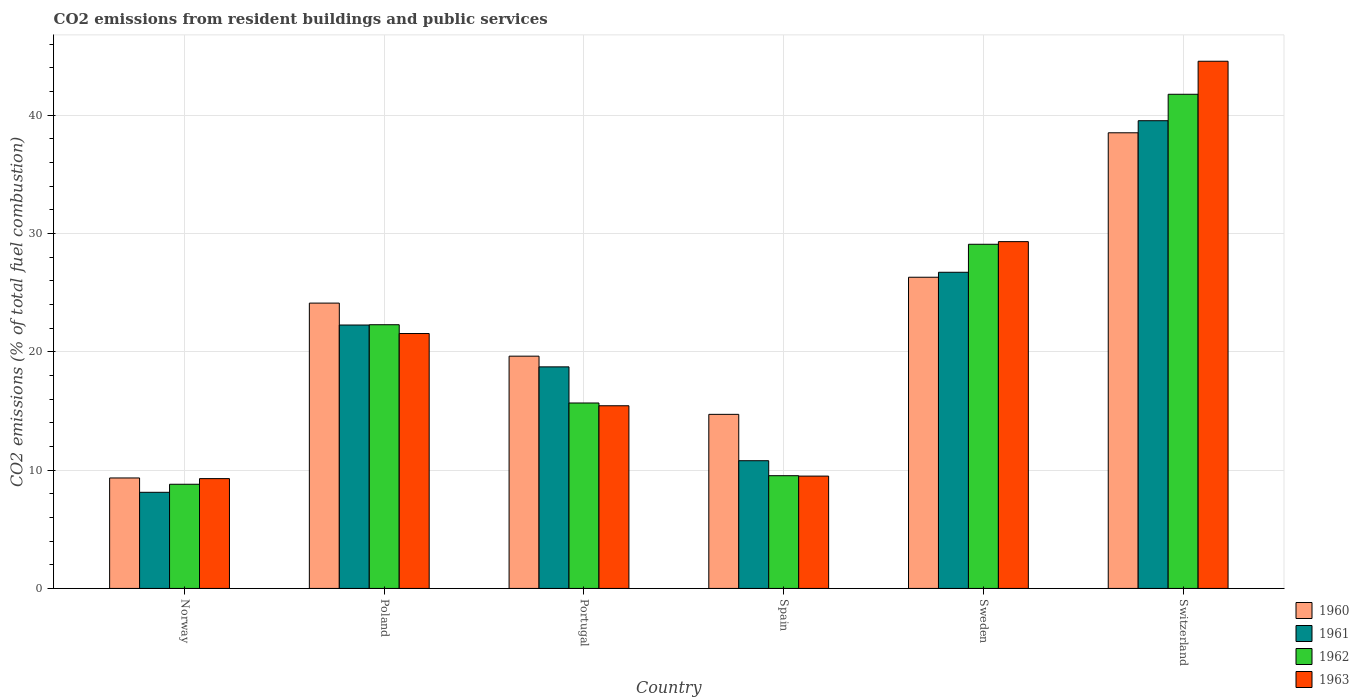How many different coloured bars are there?
Your response must be concise. 4. Are the number of bars per tick equal to the number of legend labels?
Offer a very short reply. Yes. How many bars are there on the 1st tick from the left?
Make the answer very short. 4. What is the total CO2 emitted in 1961 in Poland?
Offer a very short reply. 22.27. Across all countries, what is the maximum total CO2 emitted in 1962?
Ensure brevity in your answer.  41.78. Across all countries, what is the minimum total CO2 emitted in 1960?
Provide a succinct answer. 9.34. In which country was the total CO2 emitted in 1961 maximum?
Keep it short and to the point. Switzerland. What is the total total CO2 emitted in 1960 in the graph?
Make the answer very short. 132.65. What is the difference between the total CO2 emitted in 1963 in Poland and that in Portugal?
Offer a terse response. 6.11. What is the difference between the total CO2 emitted in 1963 in Portugal and the total CO2 emitted in 1960 in Poland?
Ensure brevity in your answer.  -8.68. What is the average total CO2 emitted in 1963 per country?
Your response must be concise. 21.61. What is the difference between the total CO2 emitted of/in 1961 and total CO2 emitted of/in 1960 in Poland?
Offer a terse response. -1.85. What is the ratio of the total CO2 emitted in 1963 in Norway to that in Sweden?
Your answer should be compact. 0.32. Is the total CO2 emitted in 1962 in Portugal less than that in Spain?
Keep it short and to the point. No. What is the difference between the highest and the second highest total CO2 emitted in 1963?
Give a very brief answer. -23.02. What is the difference between the highest and the lowest total CO2 emitted in 1963?
Keep it short and to the point. 35.29. In how many countries, is the total CO2 emitted in 1960 greater than the average total CO2 emitted in 1960 taken over all countries?
Provide a short and direct response. 3. Is it the case that in every country, the sum of the total CO2 emitted in 1960 and total CO2 emitted in 1962 is greater than the sum of total CO2 emitted in 1963 and total CO2 emitted in 1961?
Provide a short and direct response. No. What does the 3rd bar from the left in Poland represents?
Your answer should be compact. 1962. What does the 1st bar from the right in Poland represents?
Give a very brief answer. 1963. How many bars are there?
Keep it short and to the point. 24. Does the graph contain grids?
Make the answer very short. Yes. What is the title of the graph?
Give a very brief answer. CO2 emissions from resident buildings and public services. What is the label or title of the X-axis?
Offer a very short reply. Country. What is the label or title of the Y-axis?
Your answer should be very brief. CO2 emissions (% of total fuel combustion). What is the CO2 emissions (% of total fuel combustion) of 1960 in Norway?
Offer a very short reply. 9.34. What is the CO2 emissions (% of total fuel combustion) in 1961 in Norway?
Keep it short and to the point. 8.13. What is the CO2 emissions (% of total fuel combustion) in 1962 in Norway?
Your answer should be very brief. 8.81. What is the CO2 emissions (% of total fuel combustion) in 1963 in Norway?
Provide a short and direct response. 9.28. What is the CO2 emissions (% of total fuel combustion) of 1960 in Poland?
Keep it short and to the point. 24.12. What is the CO2 emissions (% of total fuel combustion) in 1961 in Poland?
Provide a short and direct response. 22.27. What is the CO2 emissions (% of total fuel combustion) of 1962 in Poland?
Keep it short and to the point. 22.3. What is the CO2 emissions (% of total fuel combustion) in 1963 in Poland?
Your response must be concise. 21.55. What is the CO2 emissions (% of total fuel combustion) of 1960 in Portugal?
Offer a terse response. 19.64. What is the CO2 emissions (% of total fuel combustion) in 1961 in Portugal?
Keep it short and to the point. 18.73. What is the CO2 emissions (% of total fuel combustion) in 1962 in Portugal?
Make the answer very short. 15.68. What is the CO2 emissions (% of total fuel combustion) in 1963 in Portugal?
Ensure brevity in your answer.  15.44. What is the CO2 emissions (% of total fuel combustion) of 1960 in Spain?
Provide a short and direct response. 14.72. What is the CO2 emissions (% of total fuel combustion) of 1961 in Spain?
Your answer should be very brief. 10.8. What is the CO2 emissions (% of total fuel combustion) in 1962 in Spain?
Offer a terse response. 9.53. What is the CO2 emissions (% of total fuel combustion) of 1963 in Spain?
Give a very brief answer. 9.5. What is the CO2 emissions (% of total fuel combustion) of 1960 in Sweden?
Keep it short and to the point. 26.31. What is the CO2 emissions (% of total fuel combustion) in 1961 in Sweden?
Your answer should be very brief. 26.73. What is the CO2 emissions (% of total fuel combustion) in 1962 in Sweden?
Ensure brevity in your answer.  29.1. What is the CO2 emissions (% of total fuel combustion) in 1963 in Sweden?
Make the answer very short. 29.32. What is the CO2 emissions (% of total fuel combustion) of 1960 in Switzerland?
Provide a short and direct response. 38.52. What is the CO2 emissions (% of total fuel combustion) in 1961 in Switzerland?
Make the answer very short. 39.54. What is the CO2 emissions (% of total fuel combustion) of 1962 in Switzerland?
Provide a short and direct response. 41.78. What is the CO2 emissions (% of total fuel combustion) of 1963 in Switzerland?
Your response must be concise. 44.57. Across all countries, what is the maximum CO2 emissions (% of total fuel combustion) in 1960?
Your answer should be very brief. 38.52. Across all countries, what is the maximum CO2 emissions (% of total fuel combustion) of 1961?
Keep it short and to the point. 39.54. Across all countries, what is the maximum CO2 emissions (% of total fuel combustion) of 1962?
Offer a terse response. 41.78. Across all countries, what is the maximum CO2 emissions (% of total fuel combustion) in 1963?
Provide a short and direct response. 44.57. Across all countries, what is the minimum CO2 emissions (% of total fuel combustion) in 1960?
Keep it short and to the point. 9.34. Across all countries, what is the minimum CO2 emissions (% of total fuel combustion) in 1961?
Offer a terse response. 8.13. Across all countries, what is the minimum CO2 emissions (% of total fuel combustion) of 1962?
Your response must be concise. 8.81. Across all countries, what is the minimum CO2 emissions (% of total fuel combustion) in 1963?
Ensure brevity in your answer.  9.28. What is the total CO2 emissions (% of total fuel combustion) of 1960 in the graph?
Your answer should be compact. 132.65. What is the total CO2 emissions (% of total fuel combustion) of 1961 in the graph?
Provide a short and direct response. 126.2. What is the total CO2 emissions (% of total fuel combustion) in 1962 in the graph?
Provide a succinct answer. 127.19. What is the total CO2 emissions (% of total fuel combustion) in 1963 in the graph?
Your answer should be very brief. 129.67. What is the difference between the CO2 emissions (% of total fuel combustion) in 1960 in Norway and that in Poland?
Keep it short and to the point. -14.78. What is the difference between the CO2 emissions (% of total fuel combustion) of 1961 in Norway and that in Poland?
Your answer should be compact. -14.14. What is the difference between the CO2 emissions (% of total fuel combustion) in 1962 in Norway and that in Poland?
Your answer should be very brief. -13.49. What is the difference between the CO2 emissions (% of total fuel combustion) in 1963 in Norway and that in Poland?
Give a very brief answer. -12.27. What is the difference between the CO2 emissions (% of total fuel combustion) in 1960 in Norway and that in Portugal?
Provide a short and direct response. -10.3. What is the difference between the CO2 emissions (% of total fuel combustion) in 1961 in Norway and that in Portugal?
Offer a terse response. -10.61. What is the difference between the CO2 emissions (% of total fuel combustion) of 1962 in Norway and that in Portugal?
Ensure brevity in your answer.  -6.87. What is the difference between the CO2 emissions (% of total fuel combustion) of 1963 in Norway and that in Portugal?
Ensure brevity in your answer.  -6.16. What is the difference between the CO2 emissions (% of total fuel combustion) in 1960 in Norway and that in Spain?
Make the answer very short. -5.38. What is the difference between the CO2 emissions (% of total fuel combustion) of 1961 in Norway and that in Spain?
Make the answer very short. -2.67. What is the difference between the CO2 emissions (% of total fuel combustion) of 1962 in Norway and that in Spain?
Offer a terse response. -0.72. What is the difference between the CO2 emissions (% of total fuel combustion) of 1963 in Norway and that in Spain?
Provide a short and direct response. -0.21. What is the difference between the CO2 emissions (% of total fuel combustion) in 1960 in Norway and that in Sweden?
Ensure brevity in your answer.  -16.97. What is the difference between the CO2 emissions (% of total fuel combustion) of 1961 in Norway and that in Sweden?
Ensure brevity in your answer.  -18.6. What is the difference between the CO2 emissions (% of total fuel combustion) of 1962 in Norway and that in Sweden?
Ensure brevity in your answer.  -20.29. What is the difference between the CO2 emissions (% of total fuel combustion) of 1963 in Norway and that in Sweden?
Ensure brevity in your answer.  -20.04. What is the difference between the CO2 emissions (% of total fuel combustion) in 1960 in Norway and that in Switzerland?
Provide a short and direct response. -29.18. What is the difference between the CO2 emissions (% of total fuel combustion) of 1961 in Norway and that in Switzerland?
Make the answer very short. -31.42. What is the difference between the CO2 emissions (% of total fuel combustion) of 1962 in Norway and that in Switzerland?
Your answer should be very brief. -32.97. What is the difference between the CO2 emissions (% of total fuel combustion) in 1963 in Norway and that in Switzerland?
Ensure brevity in your answer.  -35.29. What is the difference between the CO2 emissions (% of total fuel combustion) in 1960 in Poland and that in Portugal?
Provide a short and direct response. 4.49. What is the difference between the CO2 emissions (% of total fuel combustion) of 1961 in Poland and that in Portugal?
Your answer should be very brief. 3.54. What is the difference between the CO2 emissions (% of total fuel combustion) of 1962 in Poland and that in Portugal?
Your response must be concise. 6.62. What is the difference between the CO2 emissions (% of total fuel combustion) in 1963 in Poland and that in Portugal?
Make the answer very short. 6.11. What is the difference between the CO2 emissions (% of total fuel combustion) in 1960 in Poland and that in Spain?
Provide a short and direct response. 9.41. What is the difference between the CO2 emissions (% of total fuel combustion) of 1961 in Poland and that in Spain?
Offer a very short reply. 11.47. What is the difference between the CO2 emissions (% of total fuel combustion) of 1962 in Poland and that in Spain?
Offer a very short reply. 12.76. What is the difference between the CO2 emissions (% of total fuel combustion) of 1963 in Poland and that in Spain?
Your answer should be very brief. 12.05. What is the difference between the CO2 emissions (% of total fuel combustion) of 1960 in Poland and that in Sweden?
Provide a succinct answer. -2.19. What is the difference between the CO2 emissions (% of total fuel combustion) of 1961 in Poland and that in Sweden?
Keep it short and to the point. -4.46. What is the difference between the CO2 emissions (% of total fuel combustion) in 1962 in Poland and that in Sweden?
Provide a short and direct response. -6.8. What is the difference between the CO2 emissions (% of total fuel combustion) in 1963 in Poland and that in Sweden?
Keep it short and to the point. -7.77. What is the difference between the CO2 emissions (% of total fuel combustion) in 1960 in Poland and that in Switzerland?
Your answer should be compact. -14.4. What is the difference between the CO2 emissions (% of total fuel combustion) of 1961 in Poland and that in Switzerland?
Give a very brief answer. -17.27. What is the difference between the CO2 emissions (% of total fuel combustion) in 1962 in Poland and that in Switzerland?
Your answer should be very brief. -19.48. What is the difference between the CO2 emissions (% of total fuel combustion) of 1963 in Poland and that in Switzerland?
Make the answer very short. -23.02. What is the difference between the CO2 emissions (% of total fuel combustion) in 1960 in Portugal and that in Spain?
Keep it short and to the point. 4.92. What is the difference between the CO2 emissions (% of total fuel combustion) of 1961 in Portugal and that in Spain?
Keep it short and to the point. 7.93. What is the difference between the CO2 emissions (% of total fuel combustion) in 1962 in Portugal and that in Spain?
Make the answer very short. 6.15. What is the difference between the CO2 emissions (% of total fuel combustion) of 1963 in Portugal and that in Spain?
Ensure brevity in your answer.  5.95. What is the difference between the CO2 emissions (% of total fuel combustion) of 1960 in Portugal and that in Sweden?
Offer a terse response. -6.67. What is the difference between the CO2 emissions (% of total fuel combustion) of 1961 in Portugal and that in Sweden?
Offer a very short reply. -8. What is the difference between the CO2 emissions (% of total fuel combustion) of 1962 in Portugal and that in Sweden?
Your answer should be very brief. -13.42. What is the difference between the CO2 emissions (% of total fuel combustion) in 1963 in Portugal and that in Sweden?
Offer a very short reply. -13.88. What is the difference between the CO2 emissions (% of total fuel combustion) of 1960 in Portugal and that in Switzerland?
Offer a very short reply. -18.88. What is the difference between the CO2 emissions (% of total fuel combustion) of 1961 in Portugal and that in Switzerland?
Offer a very short reply. -20.81. What is the difference between the CO2 emissions (% of total fuel combustion) in 1962 in Portugal and that in Switzerland?
Make the answer very short. -26.1. What is the difference between the CO2 emissions (% of total fuel combustion) of 1963 in Portugal and that in Switzerland?
Keep it short and to the point. -29.13. What is the difference between the CO2 emissions (% of total fuel combustion) in 1960 in Spain and that in Sweden?
Offer a very short reply. -11.59. What is the difference between the CO2 emissions (% of total fuel combustion) of 1961 in Spain and that in Sweden?
Your answer should be very brief. -15.93. What is the difference between the CO2 emissions (% of total fuel combustion) in 1962 in Spain and that in Sweden?
Your answer should be compact. -19.57. What is the difference between the CO2 emissions (% of total fuel combustion) of 1963 in Spain and that in Sweden?
Give a very brief answer. -19.82. What is the difference between the CO2 emissions (% of total fuel combustion) in 1960 in Spain and that in Switzerland?
Your answer should be compact. -23.8. What is the difference between the CO2 emissions (% of total fuel combustion) of 1961 in Spain and that in Switzerland?
Offer a terse response. -28.75. What is the difference between the CO2 emissions (% of total fuel combustion) of 1962 in Spain and that in Switzerland?
Ensure brevity in your answer.  -32.25. What is the difference between the CO2 emissions (% of total fuel combustion) in 1963 in Spain and that in Switzerland?
Ensure brevity in your answer.  -35.07. What is the difference between the CO2 emissions (% of total fuel combustion) in 1960 in Sweden and that in Switzerland?
Give a very brief answer. -12.21. What is the difference between the CO2 emissions (% of total fuel combustion) of 1961 in Sweden and that in Switzerland?
Keep it short and to the point. -12.81. What is the difference between the CO2 emissions (% of total fuel combustion) of 1962 in Sweden and that in Switzerland?
Ensure brevity in your answer.  -12.68. What is the difference between the CO2 emissions (% of total fuel combustion) in 1963 in Sweden and that in Switzerland?
Make the answer very short. -15.25. What is the difference between the CO2 emissions (% of total fuel combustion) in 1960 in Norway and the CO2 emissions (% of total fuel combustion) in 1961 in Poland?
Make the answer very short. -12.93. What is the difference between the CO2 emissions (% of total fuel combustion) of 1960 in Norway and the CO2 emissions (% of total fuel combustion) of 1962 in Poland?
Make the answer very short. -12.96. What is the difference between the CO2 emissions (% of total fuel combustion) of 1960 in Norway and the CO2 emissions (% of total fuel combustion) of 1963 in Poland?
Provide a succinct answer. -12.21. What is the difference between the CO2 emissions (% of total fuel combustion) of 1961 in Norway and the CO2 emissions (% of total fuel combustion) of 1962 in Poland?
Your response must be concise. -14.17. What is the difference between the CO2 emissions (% of total fuel combustion) in 1961 in Norway and the CO2 emissions (% of total fuel combustion) in 1963 in Poland?
Offer a very short reply. -13.42. What is the difference between the CO2 emissions (% of total fuel combustion) in 1962 in Norway and the CO2 emissions (% of total fuel combustion) in 1963 in Poland?
Your response must be concise. -12.74. What is the difference between the CO2 emissions (% of total fuel combustion) in 1960 in Norway and the CO2 emissions (% of total fuel combustion) in 1961 in Portugal?
Give a very brief answer. -9.39. What is the difference between the CO2 emissions (% of total fuel combustion) of 1960 in Norway and the CO2 emissions (% of total fuel combustion) of 1962 in Portugal?
Your answer should be compact. -6.34. What is the difference between the CO2 emissions (% of total fuel combustion) of 1960 in Norway and the CO2 emissions (% of total fuel combustion) of 1963 in Portugal?
Ensure brevity in your answer.  -6.1. What is the difference between the CO2 emissions (% of total fuel combustion) of 1961 in Norway and the CO2 emissions (% of total fuel combustion) of 1962 in Portugal?
Your answer should be compact. -7.55. What is the difference between the CO2 emissions (% of total fuel combustion) in 1961 in Norway and the CO2 emissions (% of total fuel combustion) in 1963 in Portugal?
Give a very brief answer. -7.32. What is the difference between the CO2 emissions (% of total fuel combustion) of 1962 in Norway and the CO2 emissions (% of total fuel combustion) of 1963 in Portugal?
Your answer should be compact. -6.64. What is the difference between the CO2 emissions (% of total fuel combustion) in 1960 in Norway and the CO2 emissions (% of total fuel combustion) in 1961 in Spain?
Give a very brief answer. -1.46. What is the difference between the CO2 emissions (% of total fuel combustion) in 1960 in Norway and the CO2 emissions (% of total fuel combustion) in 1962 in Spain?
Provide a short and direct response. -0.19. What is the difference between the CO2 emissions (% of total fuel combustion) of 1960 in Norway and the CO2 emissions (% of total fuel combustion) of 1963 in Spain?
Offer a very short reply. -0.16. What is the difference between the CO2 emissions (% of total fuel combustion) in 1961 in Norway and the CO2 emissions (% of total fuel combustion) in 1962 in Spain?
Provide a succinct answer. -1.4. What is the difference between the CO2 emissions (% of total fuel combustion) of 1961 in Norway and the CO2 emissions (% of total fuel combustion) of 1963 in Spain?
Give a very brief answer. -1.37. What is the difference between the CO2 emissions (% of total fuel combustion) in 1962 in Norway and the CO2 emissions (% of total fuel combustion) in 1963 in Spain?
Your answer should be very brief. -0.69. What is the difference between the CO2 emissions (% of total fuel combustion) of 1960 in Norway and the CO2 emissions (% of total fuel combustion) of 1961 in Sweden?
Offer a very short reply. -17.39. What is the difference between the CO2 emissions (% of total fuel combustion) in 1960 in Norway and the CO2 emissions (% of total fuel combustion) in 1962 in Sweden?
Provide a short and direct response. -19.76. What is the difference between the CO2 emissions (% of total fuel combustion) of 1960 in Norway and the CO2 emissions (% of total fuel combustion) of 1963 in Sweden?
Make the answer very short. -19.98. What is the difference between the CO2 emissions (% of total fuel combustion) of 1961 in Norway and the CO2 emissions (% of total fuel combustion) of 1962 in Sweden?
Ensure brevity in your answer.  -20.97. What is the difference between the CO2 emissions (% of total fuel combustion) of 1961 in Norway and the CO2 emissions (% of total fuel combustion) of 1963 in Sweden?
Provide a short and direct response. -21.19. What is the difference between the CO2 emissions (% of total fuel combustion) of 1962 in Norway and the CO2 emissions (% of total fuel combustion) of 1963 in Sweden?
Ensure brevity in your answer.  -20.51. What is the difference between the CO2 emissions (% of total fuel combustion) of 1960 in Norway and the CO2 emissions (% of total fuel combustion) of 1961 in Switzerland?
Your answer should be compact. -30.2. What is the difference between the CO2 emissions (% of total fuel combustion) of 1960 in Norway and the CO2 emissions (% of total fuel combustion) of 1962 in Switzerland?
Your answer should be very brief. -32.44. What is the difference between the CO2 emissions (% of total fuel combustion) in 1960 in Norway and the CO2 emissions (% of total fuel combustion) in 1963 in Switzerland?
Make the answer very short. -35.23. What is the difference between the CO2 emissions (% of total fuel combustion) of 1961 in Norway and the CO2 emissions (% of total fuel combustion) of 1962 in Switzerland?
Make the answer very short. -33.65. What is the difference between the CO2 emissions (% of total fuel combustion) of 1961 in Norway and the CO2 emissions (% of total fuel combustion) of 1963 in Switzerland?
Provide a succinct answer. -36.44. What is the difference between the CO2 emissions (% of total fuel combustion) in 1962 in Norway and the CO2 emissions (% of total fuel combustion) in 1963 in Switzerland?
Your response must be concise. -35.76. What is the difference between the CO2 emissions (% of total fuel combustion) of 1960 in Poland and the CO2 emissions (% of total fuel combustion) of 1961 in Portugal?
Your answer should be very brief. 5.39. What is the difference between the CO2 emissions (% of total fuel combustion) of 1960 in Poland and the CO2 emissions (% of total fuel combustion) of 1962 in Portugal?
Offer a very short reply. 8.44. What is the difference between the CO2 emissions (% of total fuel combustion) in 1960 in Poland and the CO2 emissions (% of total fuel combustion) in 1963 in Portugal?
Ensure brevity in your answer.  8.68. What is the difference between the CO2 emissions (% of total fuel combustion) in 1961 in Poland and the CO2 emissions (% of total fuel combustion) in 1962 in Portugal?
Provide a short and direct response. 6.59. What is the difference between the CO2 emissions (% of total fuel combustion) of 1961 in Poland and the CO2 emissions (% of total fuel combustion) of 1963 in Portugal?
Your answer should be compact. 6.83. What is the difference between the CO2 emissions (% of total fuel combustion) in 1962 in Poland and the CO2 emissions (% of total fuel combustion) in 1963 in Portugal?
Give a very brief answer. 6.85. What is the difference between the CO2 emissions (% of total fuel combustion) of 1960 in Poland and the CO2 emissions (% of total fuel combustion) of 1961 in Spain?
Your answer should be compact. 13.32. What is the difference between the CO2 emissions (% of total fuel combustion) in 1960 in Poland and the CO2 emissions (% of total fuel combustion) in 1962 in Spain?
Offer a very short reply. 14.59. What is the difference between the CO2 emissions (% of total fuel combustion) of 1960 in Poland and the CO2 emissions (% of total fuel combustion) of 1963 in Spain?
Your answer should be compact. 14.63. What is the difference between the CO2 emissions (% of total fuel combustion) in 1961 in Poland and the CO2 emissions (% of total fuel combustion) in 1962 in Spain?
Your answer should be very brief. 12.74. What is the difference between the CO2 emissions (% of total fuel combustion) in 1961 in Poland and the CO2 emissions (% of total fuel combustion) in 1963 in Spain?
Make the answer very short. 12.77. What is the difference between the CO2 emissions (% of total fuel combustion) in 1962 in Poland and the CO2 emissions (% of total fuel combustion) in 1963 in Spain?
Make the answer very short. 12.8. What is the difference between the CO2 emissions (% of total fuel combustion) in 1960 in Poland and the CO2 emissions (% of total fuel combustion) in 1961 in Sweden?
Your response must be concise. -2.61. What is the difference between the CO2 emissions (% of total fuel combustion) in 1960 in Poland and the CO2 emissions (% of total fuel combustion) in 1962 in Sweden?
Give a very brief answer. -4.97. What is the difference between the CO2 emissions (% of total fuel combustion) in 1960 in Poland and the CO2 emissions (% of total fuel combustion) in 1963 in Sweden?
Your answer should be very brief. -5.2. What is the difference between the CO2 emissions (% of total fuel combustion) in 1961 in Poland and the CO2 emissions (% of total fuel combustion) in 1962 in Sweden?
Offer a terse response. -6.83. What is the difference between the CO2 emissions (% of total fuel combustion) in 1961 in Poland and the CO2 emissions (% of total fuel combustion) in 1963 in Sweden?
Your response must be concise. -7.05. What is the difference between the CO2 emissions (% of total fuel combustion) of 1962 in Poland and the CO2 emissions (% of total fuel combustion) of 1963 in Sweden?
Provide a short and direct response. -7.02. What is the difference between the CO2 emissions (% of total fuel combustion) of 1960 in Poland and the CO2 emissions (% of total fuel combustion) of 1961 in Switzerland?
Offer a very short reply. -15.42. What is the difference between the CO2 emissions (% of total fuel combustion) of 1960 in Poland and the CO2 emissions (% of total fuel combustion) of 1962 in Switzerland?
Your answer should be compact. -17.66. What is the difference between the CO2 emissions (% of total fuel combustion) of 1960 in Poland and the CO2 emissions (% of total fuel combustion) of 1963 in Switzerland?
Ensure brevity in your answer.  -20.45. What is the difference between the CO2 emissions (% of total fuel combustion) of 1961 in Poland and the CO2 emissions (% of total fuel combustion) of 1962 in Switzerland?
Provide a short and direct response. -19.51. What is the difference between the CO2 emissions (% of total fuel combustion) of 1961 in Poland and the CO2 emissions (% of total fuel combustion) of 1963 in Switzerland?
Your response must be concise. -22.3. What is the difference between the CO2 emissions (% of total fuel combustion) of 1962 in Poland and the CO2 emissions (% of total fuel combustion) of 1963 in Switzerland?
Provide a succinct answer. -22.28. What is the difference between the CO2 emissions (% of total fuel combustion) of 1960 in Portugal and the CO2 emissions (% of total fuel combustion) of 1961 in Spain?
Keep it short and to the point. 8.84. What is the difference between the CO2 emissions (% of total fuel combustion) in 1960 in Portugal and the CO2 emissions (% of total fuel combustion) in 1962 in Spain?
Your response must be concise. 10.11. What is the difference between the CO2 emissions (% of total fuel combustion) of 1960 in Portugal and the CO2 emissions (% of total fuel combustion) of 1963 in Spain?
Your answer should be very brief. 10.14. What is the difference between the CO2 emissions (% of total fuel combustion) in 1961 in Portugal and the CO2 emissions (% of total fuel combustion) in 1962 in Spain?
Your answer should be compact. 9.2. What is the difference between the CO2 emissions (% of total fuel combustion) in 1961 in Portugal and the CO2 emissions (% of total fuel combustion) in 1963 in Spain?
Your answer should be very brief. 9.23. What is the difference between the CO2 emissions (% of total fuel combustion) of 1962 in Portugal and the CO2 emissions (% of total fuel combustion) of 1963 in Spain?
Offer a very short reply. 6.18. What is the difference between the CO2 emissions (% of total fuel combustion) in 1960 in Portugal and the CO2 emissions (% of total fuel combustion) in 1961 in Sweden?
Make the answer very short. -7.09. What is the difference between the CO2 emissions (% of total fuel combustion) of 1960 in Portugal and the CO2 emissions (% of total fuel combustion) of 1962 in Sweden?
Offer a terse response. -9.46. What is the difference between the CO2 emissions (% of total fuel combustion) in 1960 in Portugal and the CO2 emissions (% of total fuel combustion) in 1963 in Sweden?
Your response must be concise. -9.68. What is the difference between the CO2 emissions (% of total fuel combustion) of 1961 in Portugal and the CO2 emissions (% of total fuel combustion) of 1962 in Sweden?
Give a very brief answer. -10.36. What is the difference between the CO2 emissions (% of total fuel combustion) of 1961 in Portugal and the CO2 emissions (% of total fuel combustion) of 1963 in Sweden?
Give a very brief answer. -10.59. What is the difference between the CO2 emissions (% of total fuel combustion) of 1962 in Portugal and the CO2 emissions (% of total fuel combustion) of 1963 in Sweden?
Offer a very short reply. -13.64. What is the difference between the CO2 emissions (% of total fuel combustion) of 1960 in Portugal and the CO2 emissions (% of total fuel combustion) of 1961 in Switzerland?
Ensure brevity in your answer.  -19.91. What is the difference between the CO2 emissions (% of total fuel combustion) in 1960 in Portugal and the CO2 emissions (% of total fuel combustion) in 1962 in Switzerland?
Give a very brief answer. -22.14. What is the difference between the CO2 emissions (% of total fuel combustion) of 1960 in Portugal and the CO2 emissions (% of total fuel combustion) of 1963 in Switzerland?
Your answer should be compact. -24.93. What is the difference between the CO2 emissions (% of total fuel combustion) of 1961 in Portugal and the CO2 emissions (% of total fuel combustion) of 1962 in Switzerland?
Offer a terse response. -23.05. What is the difference between the CO2 emissions (% of total fuel combustion) in 1961 in Portugal and the CO2 emissions (% of total fuel combustion) in 1963 in Switzerland?
Your answer should be compact. -25.84. What is the difference between the CO2 emissions (% of total fuel combustion) in 1962 in Portugal and the CO2 emissions (% of total fuel combustion) in 1963 in Switzerland?
Ensure brevity in your answer.  -28.89. What is the difference between the CO2 emissions (% of total fuel combustion) of 1960 in Spain and the CO2 emissions (% of total fuel combustion) of 1961 in Sweden?
Make the answer very short. -12.01. What is the difference between the CO2 emissions (% of total fuel combustion) of 1960 in Spain and the CO2 emissions (% of total fuel combustion) of 1962 in Sweden?
Keep it short and to the point. -14.38. What is the difference between the CO2 emissions (% of total fuel combustion) of 1960 in Spain and the CO2 emissions (% of total fuel combustion) of 1963 in Sweden?
Give a very brief answer. -14.6. What is the difference between the CO2 emissions (% of total fuel combustion) of 1961 in Spain and the CO2 emissions (% of total fuel combustion) of 1962 in Sweden?
Keep it short and to the point. -18.3. What is the difference between the CO2 emissions (% of total fuel combustion) in 1961 in Spain and the CO2 emissions (% of total fuel combustion) in 1963 in Sweden?
Provide a succinct answer. -18.52. What is the difference between the CO2 emissions (% of total fuel combustion) in 1962 in Spain and the CO2 emissions (% of total fuel combustion) in 1963 in Sweden?
Offer a terse response. -19.79. What is the difference between the CO2 emissions (% of total fuel combustion) in 1960 in Spain and the CO2 emissions (% of total fuel combustion) in 1961 in Switzerland?
Your answer should be compact. -24.83. What is the difference between the CO2 emissions (% of total fuel combustion) of 1960 in Spain and the CO2 emissions (% of total fuel combustion) of 1962 in Switzerland?
Provide a succinct answer. -27.06. What is the difference between the CO2 emissions (% of total fuel combustion) of 1960 in Spain and the CO2 emissions (% of total fuel combustion) of 1963 in Switzerland?
Offer a terse response. -29.85. What is the difference between the CO2 emissions (% of total fuel combustion) of 1961 in Spain and the CO2 emissions (% of total fuel combustion) of 1962 in Switzerland?
Your answer should be compact. -30.98. What is the difference between the CO2 emissions (% of total fuel combustion) in 1961 in Spain and the CO2 emissions (% of total fuel combustion) in 1963 in Switzerland?
Keep it short and to the point. -33.77. What is the difference between the CO2 emissions (% of total fuel combustion) in 1962 in Spain and the CO2 emissions (% of total fuel combustion) in 1963 in Switzerland?
Make the answer very short. -35.04. What is the difference between the CO2 emissions (% of total fuel combustion) in 1960 in Sweden and the CO2 emissions (% of total fuel combustion) in 1961 in Switzerland?
Provide a succinct answer. -13.23. What is the difference between the CO2 emissions (% of total fuel combustion) of 1960 in Sweden and the CO2 emissions (% of total fuel combustion) of 1962 in Switzerland?
Give a very brief answer. -15.47. What is the difference between the CO2 emissions (% of total fuel combustion) of 1960 in Sweden and the CO2 emissions (% of total fuel combustion) of 1963 in Switzerland?
Give a very brief answer. -18.26. What is the difference between the CO2 emissions (% of total fuel combustion) in 1961 in Sweden and the CO2 emissions (% of total fuel combustion) in 1962 in Switzerland?
Offer a very short reply. -15.05. What is the difference between the CO2 emissions (% of total fuel combustion) in 1961 in Sweden and the CO2 emissions (% of total fuel combustion) in 1963 in Switzerland?
Give a very brief answer. -17.84. What is the difference between the CO2 emissions (% of total fuel combustion) in 1962 in Sweden and the CO2 emissions (% of total fuel combustion) in 1963 in Switzerland?
Keep it short and to the point. -15.47. What is the average CO2 emissions (% of total fuel combustion) in 1960 per country?
Your answer should be compact. 22.11. What is the average CO2 emissions (% of total fuel combustion) in 1961 per country?
Ensure brevity in your answer.  21.03. What is the average CO2 emissions (% of total fuel combustion) in 1962 per country?
Your answer should be compact. 21.2. What is the average CO2 emissions (% of total fuel combustion) in 1963 per country?
Your response must be concise. 21.61. What is the difference between the CO2 emissions (% of total fuel combustion) in 1960 and CO2 emissions (% of total fuel combustion) in 1961 in Norway?
Provide a succinct answer. 1.21. What is the difference between the CO2 emissions (% of total fuel combustion) of 1960 and CO2 emissions (% of total fuel combustion) of 1962 in Norway?
Make the answer very short. 0.53. What is the difference between the CO2 emissions (% of total fuel combustion) of 1960 and CO2 emissions (% of total fuel combustion) of 1963 in Norway?
Keep it short and to the point. 0.05. What is the difference between the CO2 emissions (% of total fuel combustion) in 1961 and CO2 emissions (% of total fuel combustion) in 1962 in Norway?
Your response must be concise. -0.68. What is the difference between the CO2 emissions (% of total fuel combustion) in 1961 and CO2 emissions (% of total fuel combustion) in 1963 in Norway?
Offer a terse response. -1.16. What is the difference between the CO2 emissions (% of total fuel combustion) of 1962 and CO2 emissions (% of total fuel combustion) of 1963 in Norway?
Keep it short and to the point. -0.48. What is the difference between the CO2 emissions (% of total fuel combustion) in 1960 and CO2 emissions (% of total fuel combustion) in 1961 in Poland?
Give a very brief answer. 1.85. What is the difference between the CO2 emissions (% of total fuel combustion) of 1960 and CO2 emissions (% of total fuel combustion) of 1962 in Poland?
Offer a terse response. 1.83. What is the difference between the CO2 emissions (% of total fuel combustion) in 1960 and CO2 emissions (% of total fuel combustion) in 1963 in Poland?
Give a very brief answer. 2.57. What is the difference between the CO2 emissions (% of total fuel combustion) in 1961 and CO2 emissions (% of total fuel combustion) in 1962 in Poland?
Offer a very short reply. -0.02. What is the difference between the CO2 emissions (% of total fuel combustion) in 1961 and CO2 emissions (% of total fuel combustion) in 1963 in Poland?
Offer a very short reply. 0.72. What is the difference between the CO2 emissions (% of total fuel combustion) of 1962 and CO2 emissions (% of total fuel combustion) of 1963 in Poland?
Ensure brevity in your answer.  0.74. What is the difference between the CO2 emissions (% of total fuel combustion) of 1960 and CO2 emissions (% of total fuel combustion) of 1961 in Portugal?
Offer a terse response. 0.91. What is the difference between the CO2 emissions (% of total fuel combustion) in 1960 and CO2 emissions (% of total fuel combustion) in 1962 in Portugal?
Your answer should be very brief. 3.96. What is the difference between the CO2 emissions (% of total fuel combustion) of 1960 and CO2 emissions (% of total fuel combustion) of 1963 in Portugal?
Make the answer very short. 4.19. What is the difference between the CO2 emissions (% of total fuel combustion) of 1961 and CO2 emissions (% of total fuel combustion) of 1962 in Portugal?
Keep it short and to the point. 3.05. What is the difference between the CO2 emissions (% of total fuel combustion) in 1961 and CO2 emissions (% of total fuel combustion) in 1963 in Portugal?
Your response must be concise. 3.29. What is the difference between the CO2 emissions (% of total fuel combustion) of 1962 and CO2 emissions (% of total fuel combustion) of 1963 in Portugal?
Offer a terse response. 0.23. What is the difference between the CO2 emissions (% of total fuel combustion) of 1960 and CO2 emissions (% of total fuel combustion) of 1961 in Spain?
Ensure brevity in your answer.  3.92. What is the difference between the CO2 emissions (% of total fuel combustion) in 1960 and CO2 emissions (% of total fuel combustion) in 1962 in Spain?
Offer a very short reply. 5.19. What is the difference between the CO2 emissions (% of total fuel combustion) of 1960 and CO2 emissions (% of total fuel combustion) of 1963 in Spain?
Make the answer very short. 5.22. What is the difference between the CO2 emissions (% of total fuel combustion) of 1961 and CO2 emissions (% of total fuel combustion) of 1962 in Spain?
Provide a succinct answer. 1.27. What is the difference between the CO2 emissions (% of total fuel combustion) in 1961 and CO2 emissions (% of total fuel combustion) in 1963 in Spain?
Give a very brief answer. 1.3. What is the difference between the CO2 emissions (% of total fuel combustion) in 1962 and CO2 emissions (% of total fuel combustion) in 1963 in Spain?
Ensure brevity in your answer.  0.03. What is the difference between the CO2 emissions (% of total fuel combustion) of 1960 and CO2 emissions (% of total fuel combustion) of 1961 in Sweden?
Make the answer very short. -0.42. What is the difference between the CO2 emissions (% of total fuel combustion) in 1960 and CO2 emissions (% of total fuel combustion) in 1962 in Sweden?
Provide a short and direct response. -2.79. What is the difference between the CO2 emissions (% of total fuel combustion) of 1960 and CO2 emissions (% of total fuel combustion) of 1963 in Sweden?
Keep it short and to the point. -3.01. What is the difference between the CO2 emissions (% of total fuel combustion) of 1961 and CO2 emissions (% of total fuel combustion) of 1962 in Sweden?
Keep it short and to the point. -2.37. What is the difference between the CO2 emissions (% of total fuel combustion) of 1961 and CO2 emissions (% of total fuel combustion) of 1963 in Sweden?
Your answer should be very brief. -2.59. What is the difference between the CO2 emissions (% of total fuel combustion) in 1962 and CO2 emissions (% of total fuel combustion) in 1963 in Sweden?
Provide a succinct answer. -0.22. What is the difference between the CO2 emissions (% of total fuel combustion) in 1960 and CO2 emissions (% of total fuel combustion) in 1961 in Switzerland?
Your answer should be compact. -1.02. What is the difference between the CO2 emissions (% of total fuel combustion) of 1960 and CO2 emissions (% of total fuel combustion) of 1962 in Switzerland?
Offer a very short reply. -3.26. What is the difference between the CO2 emissions (% of total fuel combustion) of 1960 and CO2 emissions (% of total fuel combustion) of 1963 in Switzerland?
Ensure brevity in your answer.  -6.05. What is the difference between the CO2 emissions (% of total fuel combustion) in 1961 and CO2 emissions (% of total fuel combustion) in 1962 in Switzerland?
Keep it short and to the point. -2.23. What is the difference between the CO2 emissions (% of total fuel combustion) of 1961 and CO2 emissions (% of total fuel combustion) of 1963 in Switzerland?
Provide a short and direct response. -5.03. What is the difference between the CO2 emissions (% of total fuel combustion) of 1962 and CO2 emissions (% of total fuel combustion) of 1963 in Switzerland?
Make the answer very short. -2.79. What is the ratio of the CO2 emissions (% of total fuel combustion) in 1960 in Norway to that in Poland?
Provide a succinct answer. 0.39. What is the ratio of the CO2 emissions (% of total fuel combustion) in 1961 in Norway to that in Poland?
Provide a short and direct response. 0.36. What is the ratio of the CO2 emissions (% of total fuel combustion) of 1962 in Norway to that in Poland?
Offer a terse response. 0.4. What is the ratio of the CO2 emissions (% of total fuel combustion) in 1963 in Norway to that in Poland?
Offer a very short reply. 0.43. What is the ratio of the CO2 emissions (% of total fuel combustion) of 1960 in Norway to that in Portugal?
Provide a short and direct response. 0.48. What is the ratio of the CO2 emissions (% of total fuel combustion) of 1961 in Norway to that in Portugal?
Keep it short and to the point. 0.43. What is the ratio of the CO2 emissions (% of total fuel combustion) in 1962 in Norway to that in Portugal?
Provide a succinct answer. 0.56. What is the ratio of the CO2 emissions (% of total fuel combustion) of 1963 in Norway to that in Portugal?
Provide a short and direct response. 0.6. What is the ratio of the CO2 emissions (% of total fuel combustion) of 1960 in Norway to that in Spain?
Your answer should be compact. 0.63. What is the ratio of the CO2 emissions (% of total fuel combustion) of 1961 in Norway to that in Spain?
Make the answer very short. 0.75. What is the ratio of the CO2 emissions (% of total fuel combustion) in 1962 in Norway to that in Spain?
Your answer should be compact. 0.92. What is the ratio of the CO2 emissions (% of total fuel combustion) in 1963 in Norway to that in Spain?
Make the answer very short. 0.98. What is the ratio of the CO2 emissions (% of total fuel combustion) of 1960 in Norway to that in Sweden?
Your answer should be compact. 0.35. What is the ratio of the CO2 emissions (% of total fuel combustion) of 1961 in Norway to that in Sweden?
Keep it short and to the point. 0.3. What is the ratio of the CO2 emissions (% of total fuel combustion) in 1962 in Norway to that in Sweden?
Offer a terse response. 0.3. What is the ratio of the CO2 emissions (% of total fuel combustion) in 1963 in Norway to that in Sweden?
Offer a very short reply. 0.32. What is the ratio of the CO2 emissions (% of total fuel combustion) of 1960 in Norway to that in Switzerland?
Make the answer very short. 0.24. What is the ratio of the CO2 emissions (% of total fuel combustion) in 1961 in Norway to that in Switzerland?
Make the answer very short. 0.21. What is the ratio of the CO2 emissions (% of total fuel combustion) of 1962 in Norway to that in Switzerland?
Your answer should be compact. 0.21. What is the ratio of the CO2 emissions (% of total fuel combustion) in 1963 in Norway to that in Switzerland?
Keep it short and to the point. 0.21. What is the ratio of the CO2 emissions (% of total fuel combustion) of 1960 in Poland to that in Portugal?
Offer a terse response. 1.23. What is the ratio of the CO2 emissions (% of total fuel combustion) of 1961 in Poland to that in Portugal?
Your answer should be compact. 1.19. What is the ratio of the CO2 emissions (% of total fuel combustion) in 1962 in Poland to that in Portugal?
Make the answer very short. 1.42. What is the ratio of the CO2 emissions (% of total fuel combustion) in 1963 in Poland to that in Portugal?
Offer a terse response. 1.4. What is the ratio of the CO2 emissions (% of total fuel combustion) of 1960 in Poland to that in Spain?
Keep it short and to the point. 1.64. What is the ratio of the CO2 emissions (% of total fuel combustion) of 1961 in Poland to that in Spain?
Your answer should be compact. 2.06. What is the ratio of the CO2 emissions (% of total fuel combustion) in 1962 in Poland to that in Spain?
Provide a short and direct response. 2.34. What is the ratio of the CO2 emissions (% of total fuel combustion) of 1963 in Poland to that in Spain?
Keep it short and to the point. 2.27. What is the ratio of the CO2 emissions (% of total fuel combustion) in 1960 in Poland to that in Sweden?
Offer a terse response. 0.92. What is the ratio of the CO2 emissions (% of total fuel combustion) in 1961 in Poland to that in Sweden?
Keep it short and to the point. 0.83. What is the ratio of the CO2 emissions (% of total fuel combustion) in 1962 in Poland to that in Sweden?
Your response must be concise. 0.77. What is the ratio of the CO2 emissions (% of total fuel combustion) of 1963 in Poland to that in Sweden?
Provide a succinct answer. 0.73. What is the ratio of the CO2 emissions (% of total fuel combustion) in 1960 in Poland to that in Switzerland?
Keep it short and to the point. 0.63. What is the ratio of the CO2 emissions (% of total fuel combustion) of 1961 in Poland to that in Switzerland?
Offer a very short reply. 0.56. What is the ratio of the CO2 emissions (% of total fuel combustion) in 1962 in Poland to that in Switzerland?
Your answer should be compact. 0.53. What is the ratio of the CO2 emissions (% of total fuel combustion) of 1963 in Poland to that in Switzerland?
Make the answer very short. 0.48. What is the ratio of the CO2 emissions (% of total fuel combustion) in 1960 in Portugal to that in Spain?
Your response must be concise. 1.33. What is the ratio of the CO2 emissions (% of total fuel combustion) of 1961 in Portugal to that in Spain?
Offer a very short reply. 1.73. What is the ratio of the CO2 emissions (% of total fuel combustion) of 1962 in Portugal to that in Spain?
Keep it short and to the point. 1.64. What is the ratio of the CO2 emissions (% of total fuel combustion) in 1963 in Portugal to that in Spain?
Your answer should be compact. 1.63. What is the ratio of the CO2 emissions (% of total fuel combustion) in 1960 in Portugal to that in Sweden?
Make the answer very short. 0.75. What is the ratio of the CO2 emissions (% of total fuel combustion) in 1961 in Portugal to that in Sweden?
Offer a terse response. 0.7. What is the ratio of the CO2 emissions (% of total fuel combustion) of 1962 in Portugal to that in Sweden?
Your answer should be compact. 0.54. What is the ratio of the CO2 emissions (% of total fuel combustion) in 1963 in Portugal to that in Sweden?
Ensure brevity in your answer.  0.53. What is the ratio of the CO2 emissions (% of total fuel combustion) in 1960 in Portugal to that in Switzerland?
Your response must be concise. 0.51. What is the ratio of the CO2 emissions (% of total fuel combustion) of 1961 in Portugal to that in Switzerland?
Your answer should be compact. 0.47. What is the ratio of the CO2 emissions (% of total fuel combustion) in 1962 in Portugal to that in Switzerland?
Provide a succinct answer. 0.38. What is the ratio of the CO2 emissions (% of total fuel combustion) of 1963 in Portugal to that in Switzerland?
Ensure brevity in your answer.  0.35. What is the ratio of the CO2 emissions (% of total fuel combustion) of 1960 in Spain to that in Sweden?
Your response must be concise. 0.56. What is the ratio of the CO2 emissions (% of total fuel combustion) of 1961 in Spain to that in Sweden?
Offer a terse response. 0.4. What is the ratio of the CO2 emissions (% of total fuel combustion) of 1962 in Spain to that in Sweden?
Make the answer very short. 0.33. What is the ratio of the CO2 emissions (% of total fuel combustion) of 1963 in Spain to that in Sweden?
Your answer should be very brief. 0.32. What is the ratio of the CO2 emissions (% of total fuel combustion) in 1960 in Spain to that in Switzerland?
Make the answer very short. 0.38. What is the ratio of the CO2 emissions (% of total fuel combustion) of 1961 in Spain to that in Switzerland?
Provide a succinct answer. 0.27. What is the ratio of the CO2 emissions (% of total fuel combustion) in 1962 in Spain to that in Switzerland?
Make the answer very short. 0.23. What is the ratio of the CO2 emissions (% of total fuel combustion) in 1963 in Spain to that in Switzerland?
Provide a succinct answer. 0.21. What is the ratio of the CO2 emissions (% of total fuel combustion) of 1960 in Sweden to that in Switzerland?
Your response must be concise. 0.68. What is the ratio of the CO2 emissions (% of total fuel combustion) in 1961 in Sweden to that in Switzerland?
Provide a short and direct response. 0.68. What is the ratio of the CO2 emissions (% of total fuel combustion) of 1962 in Sweden to that in Switzerland?
Your response must be concise. 0.7. What is the ratio of the CO2 emissions (% of total fuel combustion) of 1963 in Sweden to that in Switzerland?
Your answer should be very brief. 0.66. What is the difference between the highest and the second highest CO2 emissions (% of total fuel combustion) of 1960?
Make the answer very short. 12.21. What is the difference between the highest and the second highest CO2 emissions (% of total fuel combustion) in 1961?
Make the answer very short. 12.81. What is the difference between the highest and the second highest CO2 emissions (% of total fuel combustion) of 1962?
Your answer should be very brief. 12.68. What is the difference between the highest and the second highest CO2 emissions (% of total fuel combustion) in 1963?
Your answer should be compact. 15.25. What is the difference between the highest and the lowest CO2 emissions (% of total fuel combustion) in 1960?
Offer a terse response. 29.18. What is the difference between the highest and the lowest CO2 emissions (% of total fuel combustion) in 1961?
Your answer should be very brief. 31.42. What is the difference between the highest and the lowest CO2 emissions (% of total fuel combustion) in 1962?
Ensure brevity in your answer.  32.97. What is the difference between the highest and the lowest CO2 emissions (% of total fuel combustion) of 1963?
Provide a succinct answer. 35.29. 